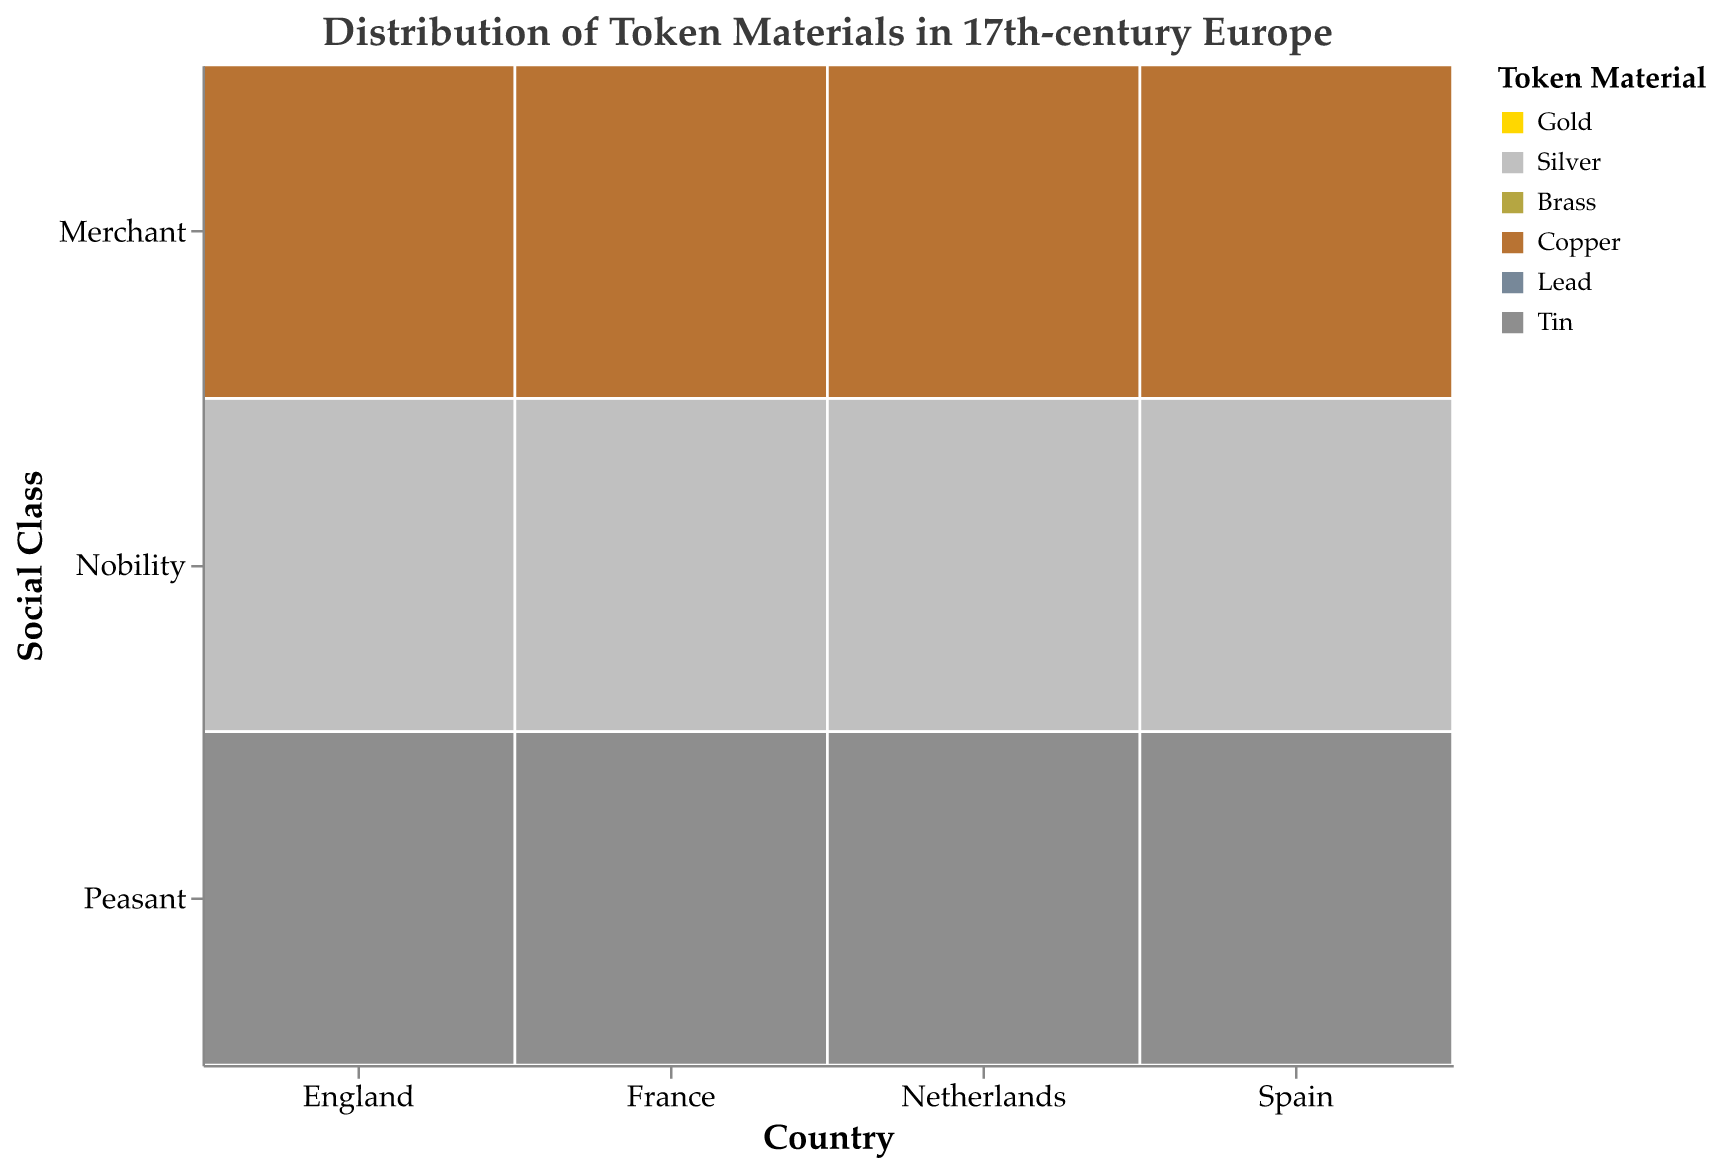What's the title of the figure? The title of the figure is usually displayed at the top of the visual. In this case, it clearly states, "Distribution of Token Materials in 17th-century Europe".
Answer: Distribution of Token Materials in 17th-century Europe Which country used the most gold for tokens among the nobility class? To find this, we need to look at the "Nobility" class across different countries and compare the frequencies for gold. Spain has the highest frequency of 55 for gold in the nobility class.
Answer: Spain How does the frequency of copper tokens used by merchants in France compare to those in England? To answer this, we compare the frequencies for copper in the merchant class between France and England. France has a frequency of 45 and England has a frequency of 40. France has 5 more copper tokens used by merchants than England.
Answer: France has 5 more What is the total frequency of tokens used by peasants in the Netherlands? We need to sum the frequencies for all token materials used by peasants in the Netherlands: Lead (80) + Tin (20).
Answer: 100 Which social class in England used the least amount of tin tokens? To find this, we compare the frequencies of tin tokens across different social classes in England. The frequency for Nobility is not listed, while Peasant is 25 and Merchant is not listed. Hence, Peasant used the least amount among the listed classes with 25.
Answer: Peasant What is the average frequency of brass tokens used by merchants across all countries? We calculate the sum of brass token frequencies for merchants in each country and divide by the number of countries: (England: 60 + France: 55 + Netherlands: 65 + Spain: 50) / 4 = 230 / 4.
Answer: 57.5 Which country has the highest proportion of lead tokens used by peasants? We need to compare the frequencies of lead tokens used by peasants across all countries. Netherlands has the highest frequency at 80.
Answer: Netherlands In which country do merchants use more copper tokens than brass tokens? Comparing the frequencies for copper and brass for each country’s merchant class. Spain has an equal frequency of 50 for both, while in other countries, brass tokens have higher or equal frequencies.
Answer: None What's the most common material used by the nobility in France? We need to compare the frequencies of different materials used by the nobility in France. Gold is 50 and Silver is 35, so Gold is the most common material used by the nobility in France.
Answer: Gold 